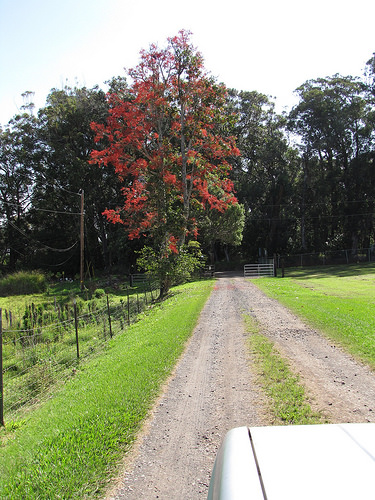<image>
Is there a road to the right of the tree? Yes. From this viewpoint, the road is positioned to the right side relative to the tree. 